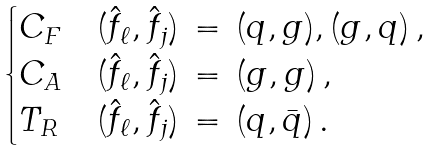<formula> <loc_0><loc_0><loc_500><loc_500>\begin{cases} C _ { F } & ( \hat { f } _ { \ell } , \hat { f } _ { j } ) \, = \, ( q , g ) , ( g , q ) \, , \\ C _ { A } & ( \hat { f } _ { \ell } , \hat { f } _ { j } ) \, = \, ( g , g ) \, , \\ T _ { R } & ( \hat { f } _ { \ell } , \hat { f } _ { j } ) \, = \, ( q , \bar { q } ) \, . \end{cases}</formula> 